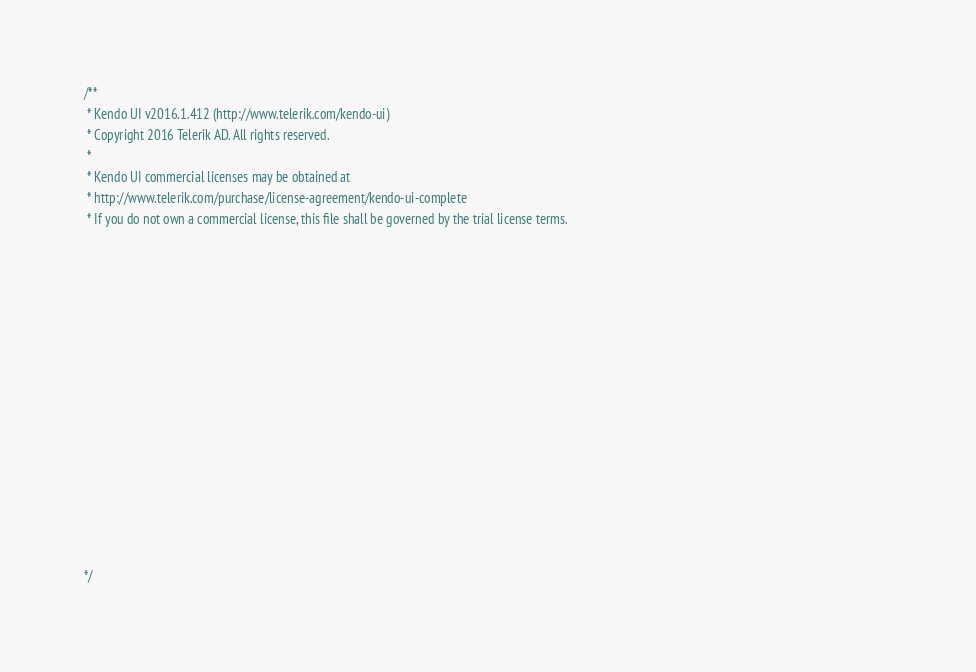Convert code to text. <code><loc_0><loc_0><loc_500><loc_500><_JavaScript_>/** 
 * Kendo UI v2016.1.412 (http://www.telerik.com/kendo-ui)                                                                                                                                               
 * Copyright 2016 Telerik AD. All rights reserved.                                                                                                                                                      
 *                                                                                                                                                                                                      
 * Kendo UI commercial licenses may be obtained at                                                                                                                                                      
 * http://www.telerik.com/purchase/license-agreement/kendo-ui-complete                                                                                                                                  
 * If you do not own a commercial license, this file shall be governed by the trial license terms.                                                                                                      
                                                                                                                                                                                                       
                                                                                                                                                                                                       
                                                                                                                                                                                                       
                                                                                                                                                                                                       
                                                                                                                                                                                                       
                                                                                                                                                                                                       
                                                                                                                                                                                                       
                                                                                                                                                                                                       
                                                                                                                                                                                                       
                                                                                                                                                                                                       
                                                                                                                                                                                                       
                                                                                                                                                                                                       
                                                                                                                                                                                                       
                                                                                                                                                                                                       
                                                                                                                                                                                                       

*/</code> 